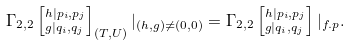Convert formula to latex. <formula><loc_0><loc_0><loc_500><loc_500>\Gamma _ { 2 , 2 } \left [ ^ { h | p _ { i } , p _ { j } } _ { g | q _ { i } , q _ { j } } \right ] _ { ( T , U ) } | _ { ( h , g ) \ne ( 0 , 0 ) } = \Gamma _ { 2 , 2 } \left [ ^ { h | p _ { i } , p _ { j } } _ { g | q _ { i } , q _ { j } } \right ] | _ { f . p } .</formula> 